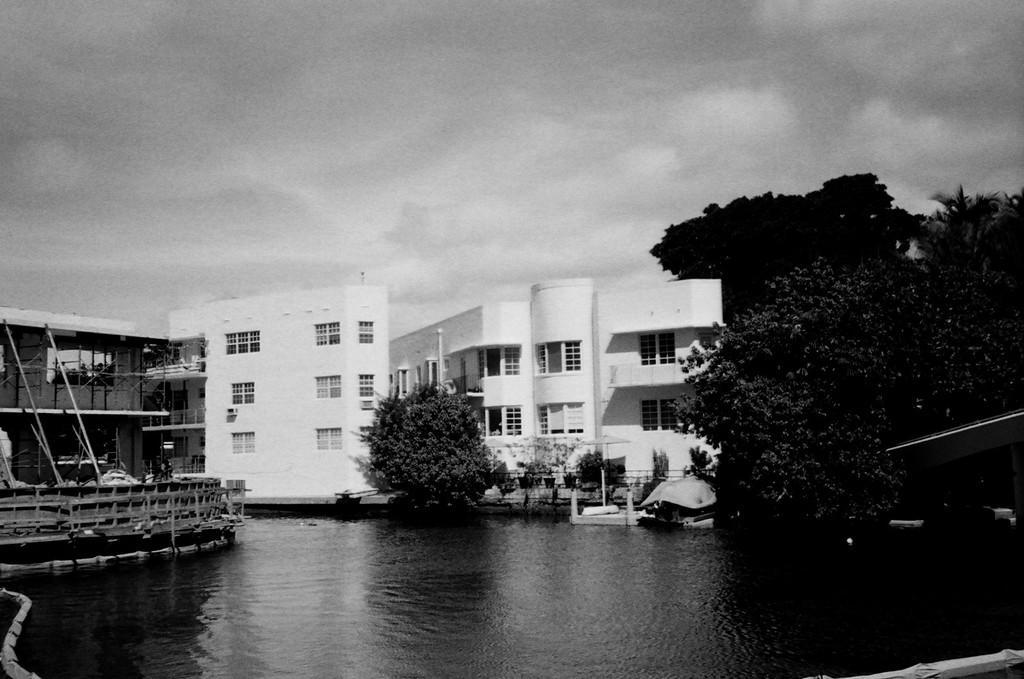How would you summarize this image in a sentence or two? This is a black and white picture. We can see water. There are few trees and buildings in the background. Sky is cloudy. 